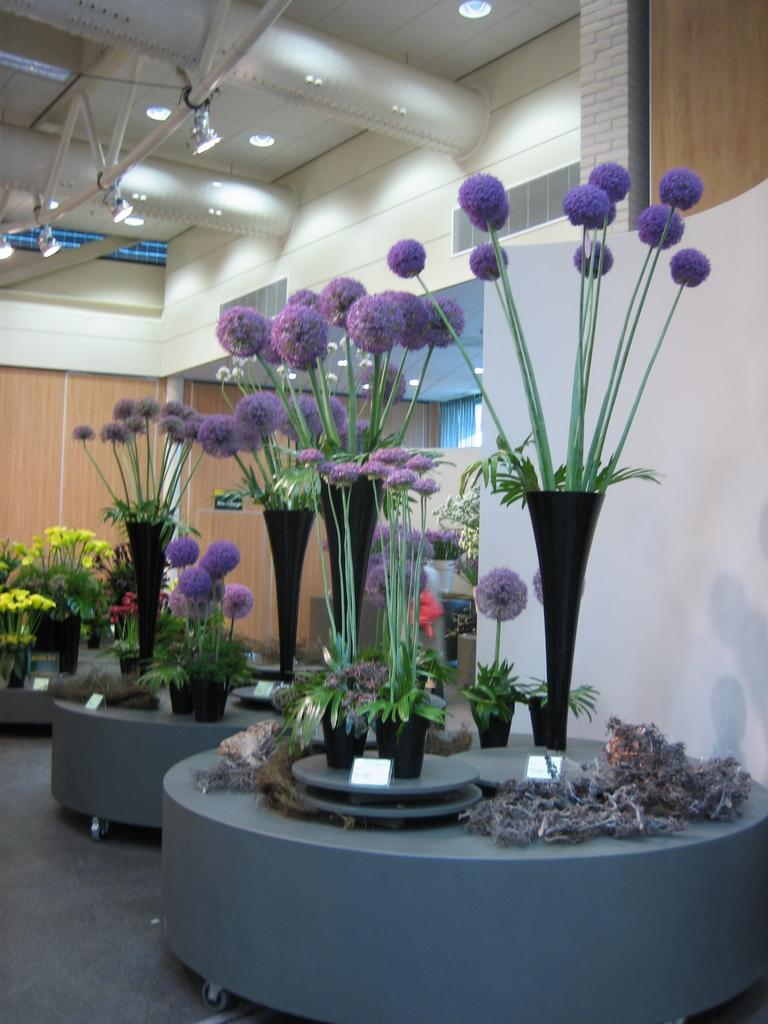What objects are present in the image? There are flower vases in the image. What can be seen in the background of the image? There is a wall and lights in the background of the image. How does the earthquake affect the flower vases in the image? There is no earthquake present in the image, so its effects cannot be observed. 